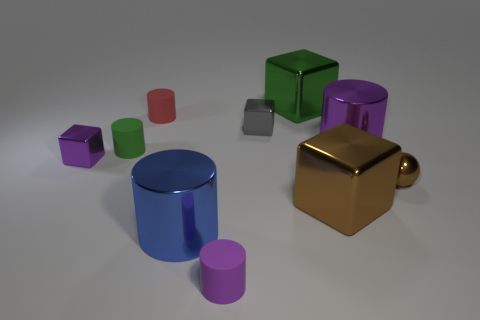Subtract all brown cylinders. Subtract all green balls. How many cylinders are left? 5 Subtract all spheres. How many objects are left? 9 Subtract 0 red spheres. How many objects are left? 10 Subtract all big purple cylinders. Subtract all small matte cylinders. How many objects are left? 6 Add 4 small spheres. How many small spheres are left? 5 Add 3 gray blocks. How many gray blocks exist? 4 